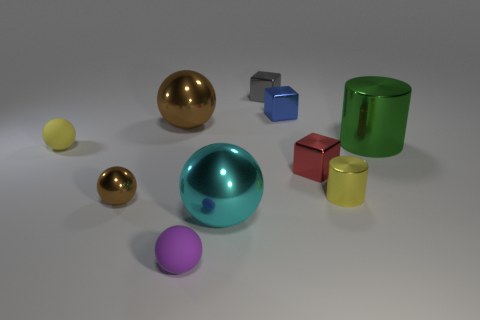How many tiny things are behind the large green shiny thing and left of the small gray metal object?
Give a very brief answer. 0. There is a block that is in front of the cylinder behind the tiny yellow sphere in front of the tiny gray thing; what is its color?
Your answer should be compact. Red. There is a brown object in front of the red metallic thing; what number of gray blocks are left of it?
Give a very brief answer. 0. What number of other objects are the same shape as the yellow shiny object?
Make the answer very short. 1. What number of things are large brown spheres or big metallic objects behind the big shiny cylinder?
Your answer should be very brief. 1. Are there more big things behind the green cylinder than tiny yellow rubber spheres that are right of the tiny red shiny object?
Offer a terse response. Yes. There is a tiny matte object in front of the small yellow thing that is left of the tiny gray metallic block that is to the left of the green shiny cylinder; what is its shape?
Ensure brevity in your answer.  Sphere. What is the shape of the rubber thing that is left of the tiny rubber sphere in front of the small red cube?
Offer a very short reply. Sphere. Are there any other objects made of the same material as the purple object?
Provide a succinct answer. Yes. What is the size of the shiny object that is the same color as the tiny metallic ball?
Keep it short and to the point. Large. 